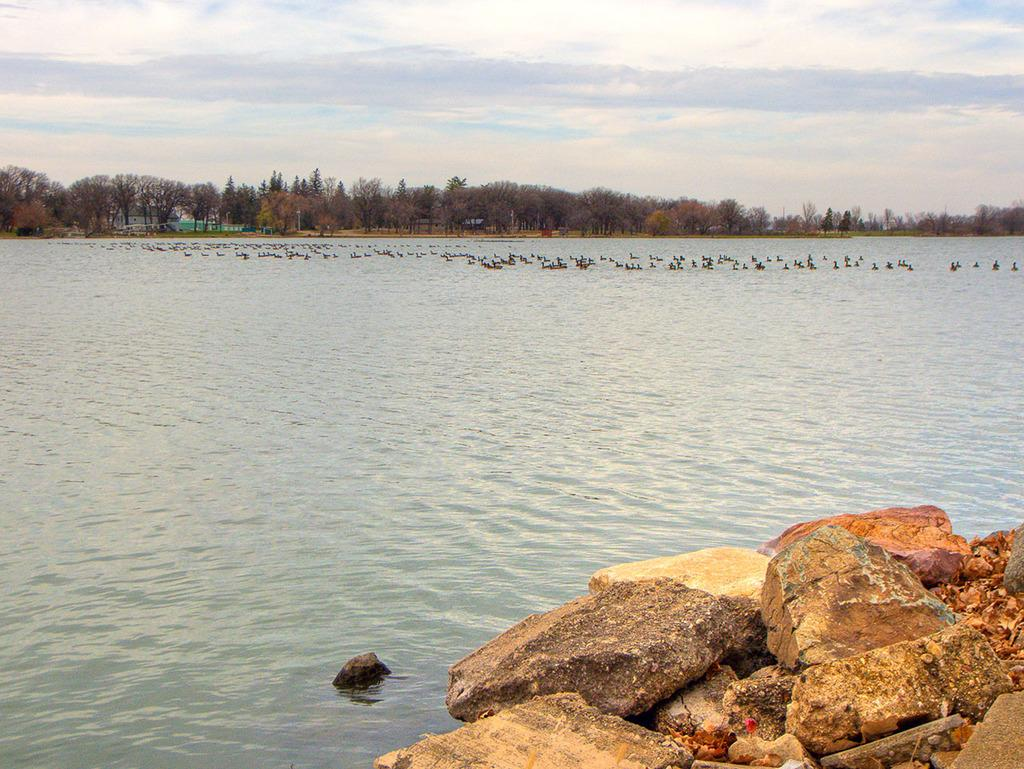What is happening in the image? There is water flowing in the image. What else can be seen in the water? There are birds in the water. What type of natural features are visible in the image? There are rocks and trees visible in the image. What is visible in the background of the image? The sky is visible in the image. What type of silver is being used to catch the birds in the image? There is no silver or bird-catching device present in the image. How many frogs can be seen on the rocks in the image? There are no frogs visible in the image; only birds are present in the water. 